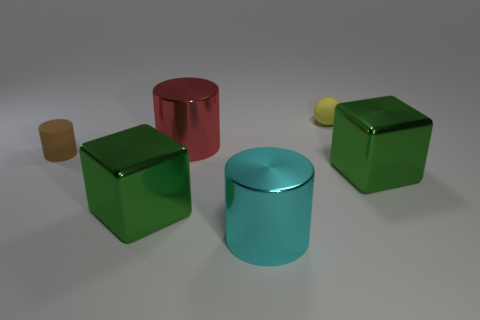Subtract 1 cylinders. How many cylinders are left? 2 Subtract all brown matte cylinders. How many cylinders are left? 2 Add 3 tiny objects. How many objects exist? 9 Subtract all purple cylinders. Subtract all purple blocks. How many cylinders are left? 3 Subtract all balls. How many objects are left? 5 Subtract all brown cubes. Subtract all red objects. How many objects are left? 5 Add 6 big cyan cylinders. How many big cyan cylinders are left? 7 Add 4 brown cylinders. How many brown cylinders exist? 5 Subtract 0 purple cubes. How many objects are left? 6 